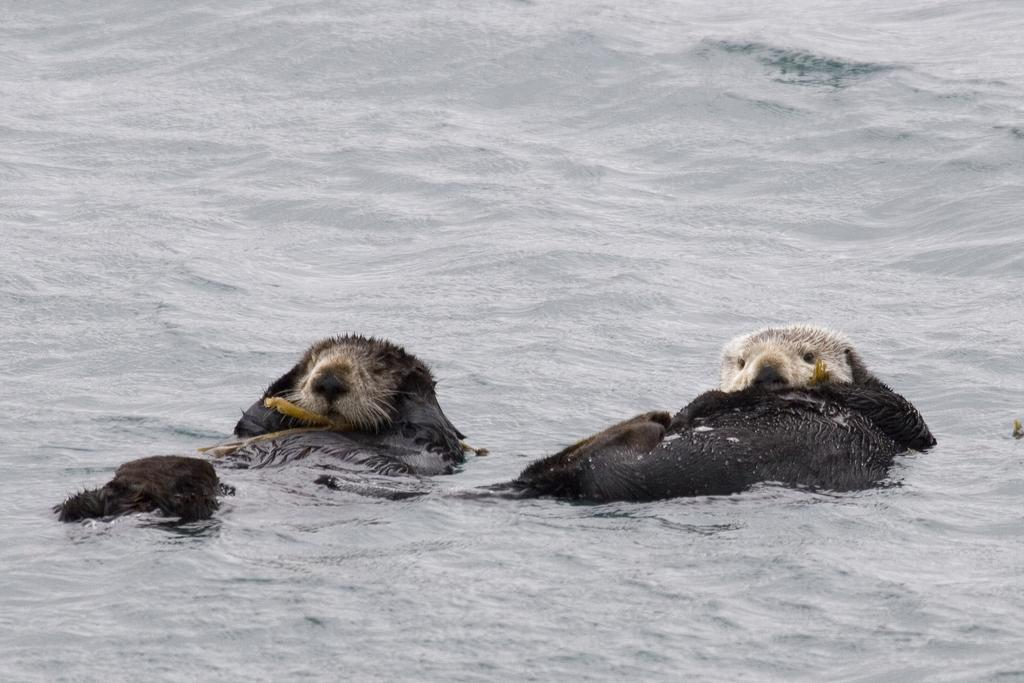How many animals are present in the image? There are 2 animals in the image. What colors are the animals? The animals are black and white in color. Where are the animals located in the image? The animals are in the water. What type of scarecrow is present in the image? There is no scarecrow present in the image; it features 2 black and white animals in the water. What role does the judge play in the image? There is no judge present in the image; it features 2 black and white animals in the water. 